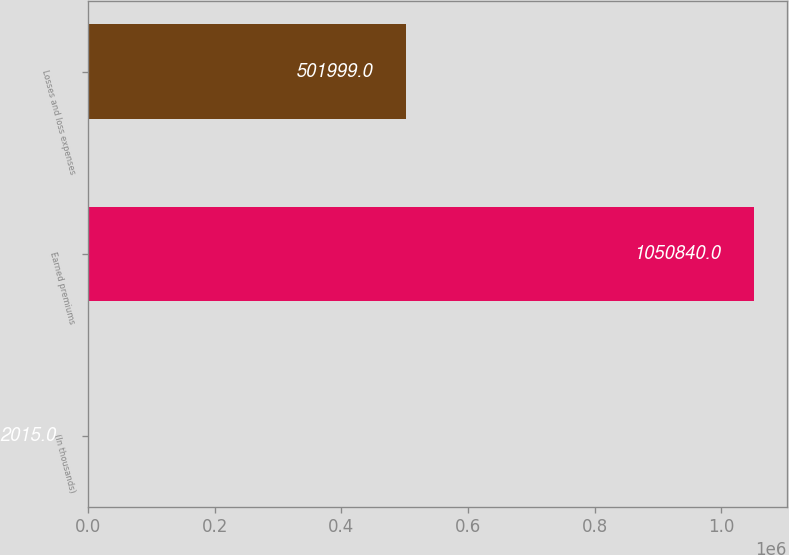Convert chart to OTSL. <chart><loc_0><loc_0><loc_500><loc_500><bar_chart><fcel>(In thousands)<fcel>Earned premiums<fcel>Losses and loss expenses<nl><fcel>2015<fcel>1.05084e+06<fcel>501999<nl></chart> 